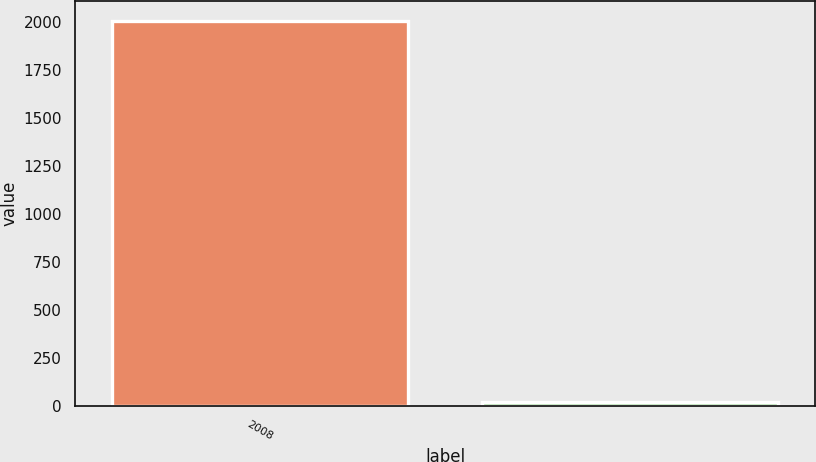Convert chart. <chart><loc_0><loc_0><loc_500><loc_500><bar_chart><fcel>2008<fcel>Unnamed: 1<nl><fcel>2006<fcel>23<nl></chart> 